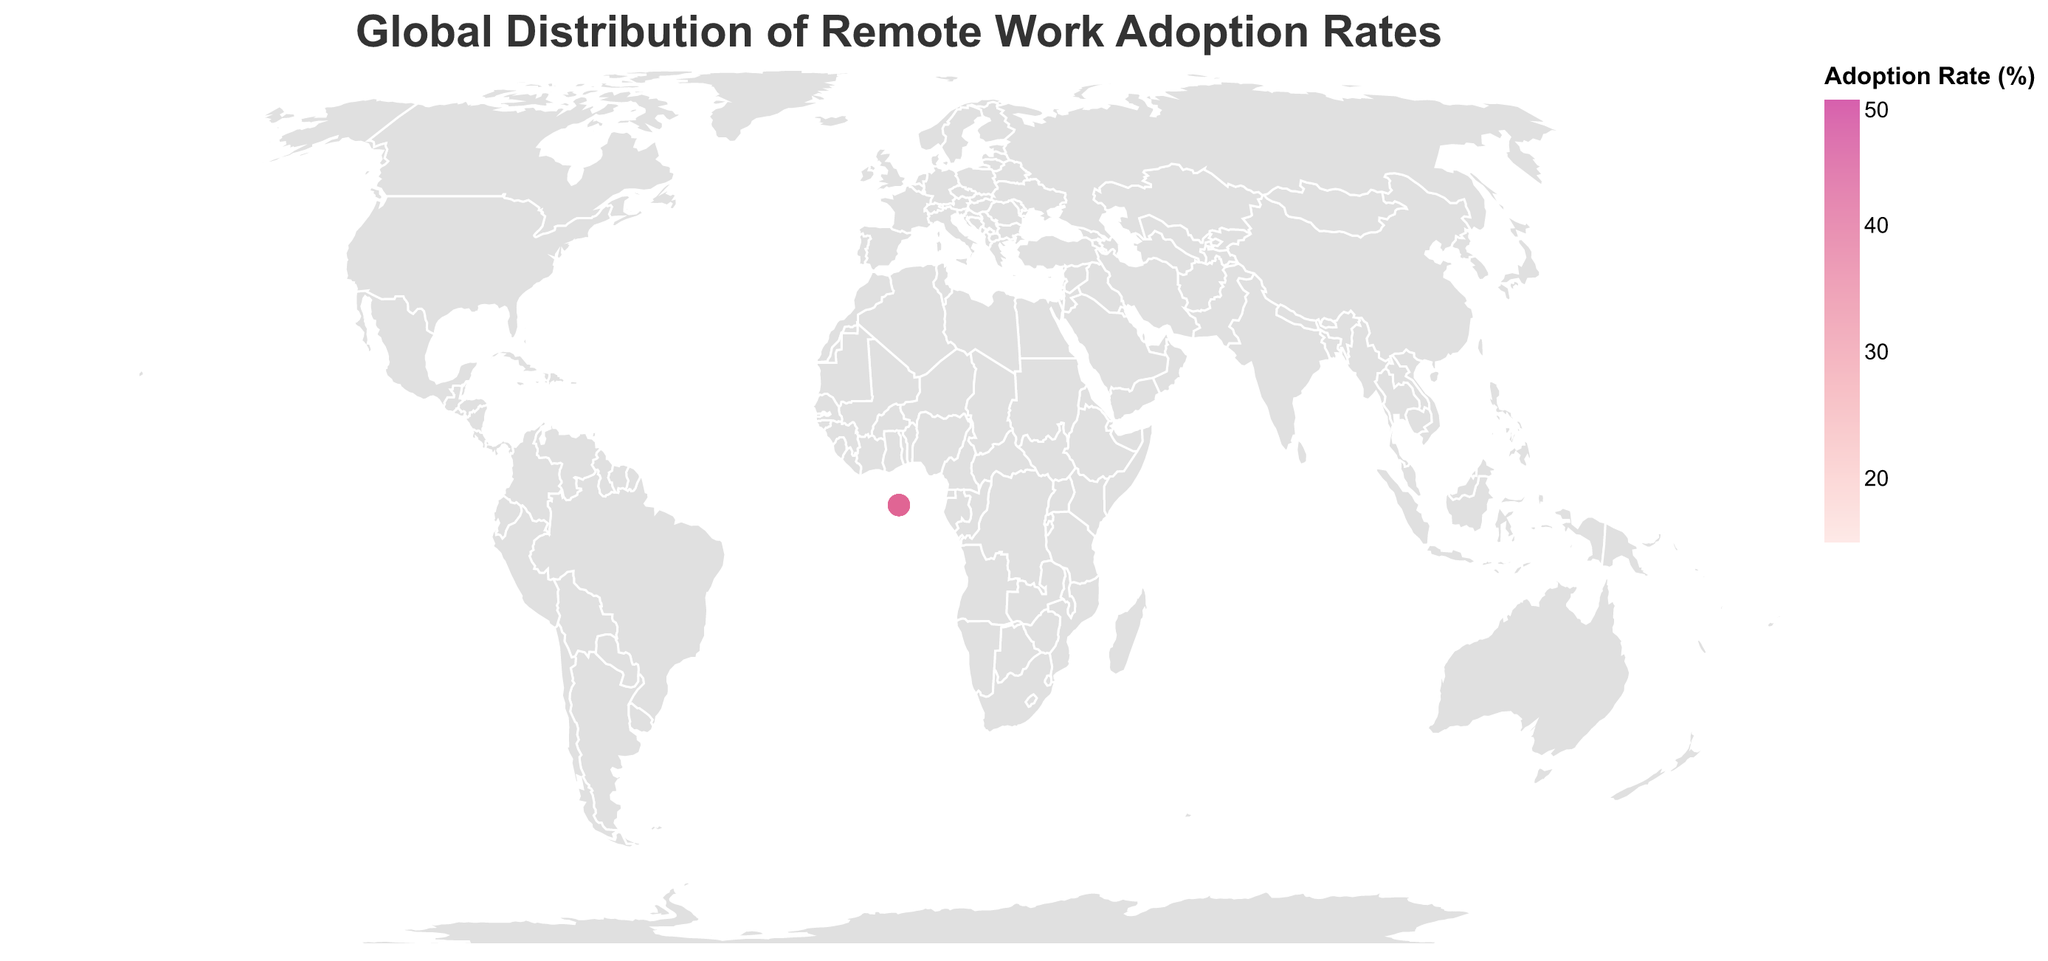What is the title of the figure? The title is usually prominently displayed at the top of the figure. Here, it reads "Global Distribution of Remote Work Adoption Rates".
Answer: Global Distribution of Remote Work Adoption Rates Which country has the highest remote work adoption rate? By examining the color intensity and the tooltip, Singapore stands out with the darkest color, indicating the highest remote work adoption rate. Confirm by checking the tooltip value.
Answer: Singapore How many countries have a remote work adoption rate above 40%? Analyze the colors and tooltips of each country on the map. The Netherlands, Singapore, Australia, New Zealand, and Denmark all have rates above 40%.
Answer: 5 What is the average remote work adoption rate for the United States and Canada? Add the remote work adoption rates of the United States and Canada (37.2 and 38.9, respectively), then divide by the number of countries (2). (37.2 + 38.9) / 2 = 38.05
Answer: 38.05 Which country has a higher remote work adoption rate, Germany or Brazil? Compare the remote work adoption rates shown in the tooltips for Germany (24.8%) and Brazil (25.6%).
Answer: Brazil What is the difference in remote work adoption rates between Sweden and the United Kingdom? Subtract the remote work adoption rate of the United Kingdom from that of Sweden (39.7 - 31.5).
Answer: 8.2 What is the range of remote work adoption rates in the figure? Identify the minimum and maximum remote work adoption rates from the data points, which are Japan (16.5) and Singapore (46.2). Compute the range as 46.2 - 16.5.
Answer: 29.7 How does the remote work adoption rate in Ireland compare to that in Switzerland? Look at the tooltips for Ireland (35.9%) and Switzerland (34.2%) and compare their values.
Answer: Ireland has a higher rate Which region (continent) appears to have a generally higher adoption of remote work based on color intensity? Observe the color intensity for countries in different continents, noting that many countries in Europe and Oceania have high-intensity colors, indicating higher adoption rates.
Answer: Europe and Oceania What is the median remote work adoption rate among all countries listed? List all remote work adoption rates, arrange them in ascending order, and identify the middle value. The rates are 16.5, 18.7, 21.4, 22.1, 24.8, 25.6, 27.3, 30.8, 31.5, 34.2, 35.9, 37.2, 38.4, 38.9, 39.7, 40.5, 41.3, 42.1, 44.6, 46.2. The median is the average of the 10th and 11th values (34.2 + 35.9) / 2 = 35.05.
Answer: 35.05 